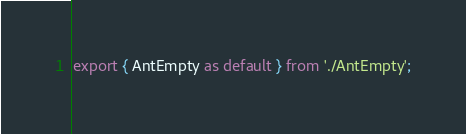<code> <loc_0><loc_0><loc_500><loc_500><_TypeScript_>export { AntEmpty as default } from './AntEmpty';
</code> 